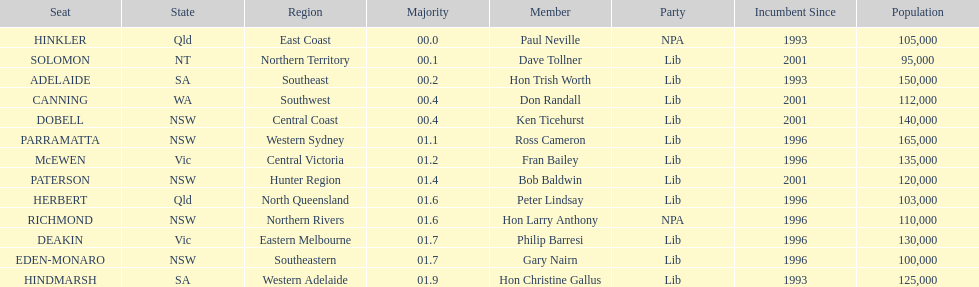Who is listed before don randall? Hon Trish Worth. 